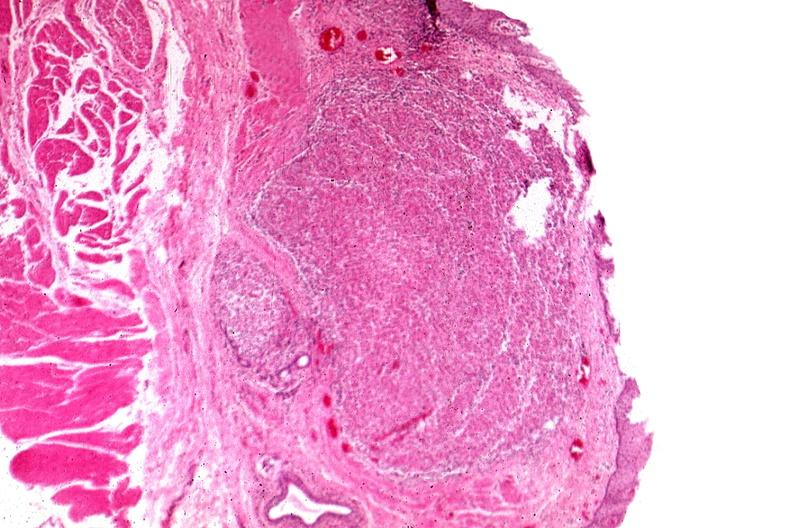where is this from?
Answer the question using a single word or phrase. Gastrointestinal system 